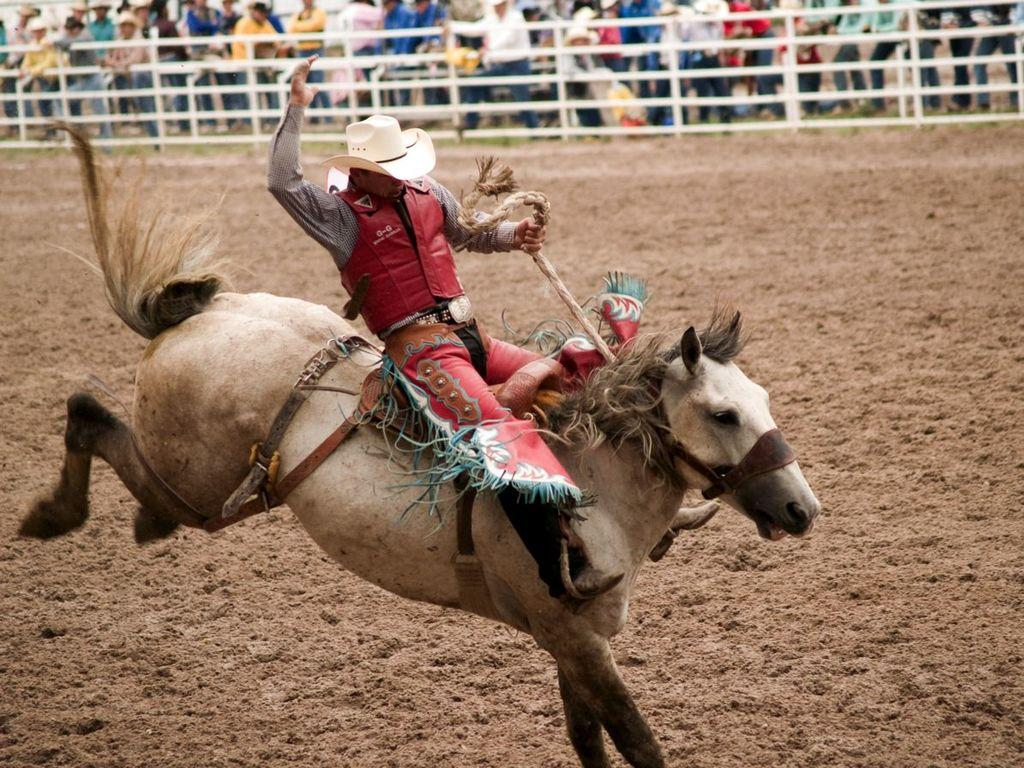What is the main subject of the image? There is a person riding a horse in the image. Where is the person riding the horse located? The person is on the ground. What is the person wearing on their head? The person is wearing a hat. What can be seen in the background of the image? There is a group of people standing near the railing at the top of the image. What type of nest can be seen in the image? There is no nest present in the image. How many bells are hanging from the horse's saddle in the image? There are no bells visible on the horse's saddle in the image. 